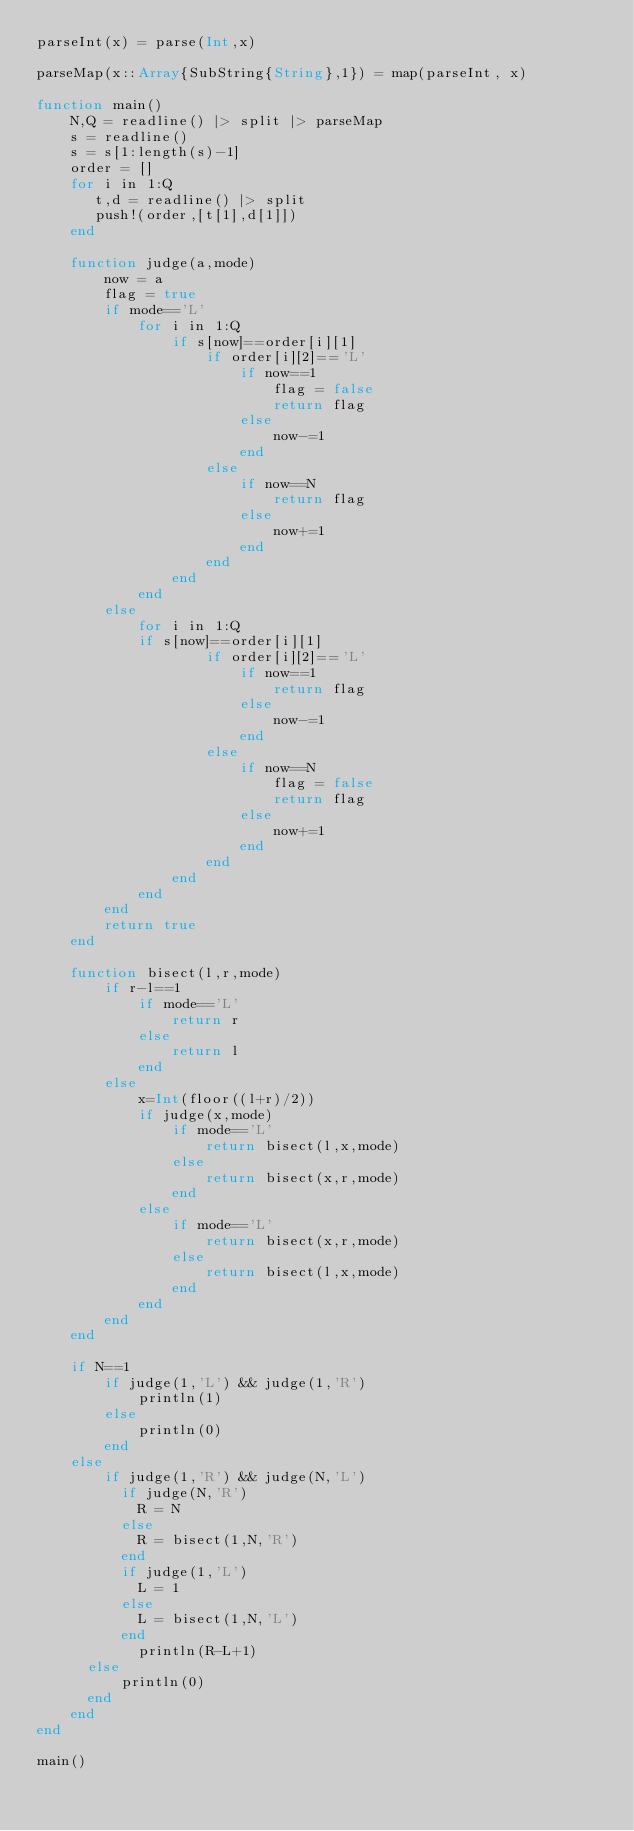Convert code to text. <code><loc_0><loc_0><loc_500><loc_500><_Julia_>parseInt(x) = parse(Int,x)

parseMap(x::Array{SubString{String},1}) = map(parseInt, x)

function main()
    N,Q = readline() |> split |> parseMap
    s = readline()
    s = s[1:length(s)-1]
    order = []
    for i in 1:Q
       t,d = readline() |> split
       push!(order,[t[1],d[1]])
    end

    function judge(a,mode)
        now = a
        flag = true
        if mode=='L'
            for i in 1:Q
                if s[now]==order[i][1]
                    if order[i][2]=='L'
                        if now==1
                            flag = false
                            return flag
                        else
                            now-=1
                        end
                    else
                        if now==N
                            return flag
                        else
                            now+=1
                        end
                    end
                end
            end
        else
            for i in 1:Q
        		if s[now]==order[i][1]
                    if order[i][2]=='L'
                        if now==1
                            return flag
                        else
                            now-=1
                        end
                    else
                        if now==N
                            flag = false
                            return flag
                        else
                            now+=1
                        end
                    end
                end
            end
        end
        return true
    end
    
    function bisect(l,r,mode)
        if r-l==1
            if mode=='L'
                return r
            else
                return l
            end
        else
            x=Int(floor((l+r)/2))
            if judge(x,mode)
                if mode=='L'
                    return bisect(l,x,mode)
                else
                    return bisect(x,r,mode)
                end
            else
                if mode=='L'
                    return bisect(x,r,mode)
                else
                    return bisect(l,x,mode)
                end
            end
        end
    end

    if N==1
        if judge(1,'L') && judge(1,'R')
            println(1)
        else
            println(0)
        end
    else
        if judge(1,'R') && judge(N,'L')
      		if judge(N,'R')
        		R = N
      		else
        		R = bisect(1,N,'R')
      		end
      		if judge(1,'L')
        		L = 1
      		else
        		L = bisect(1,N,'L')
      		end
            println(R-L+1)
    	else
      		println(0)
    	end
    end
end

main()
</code> 